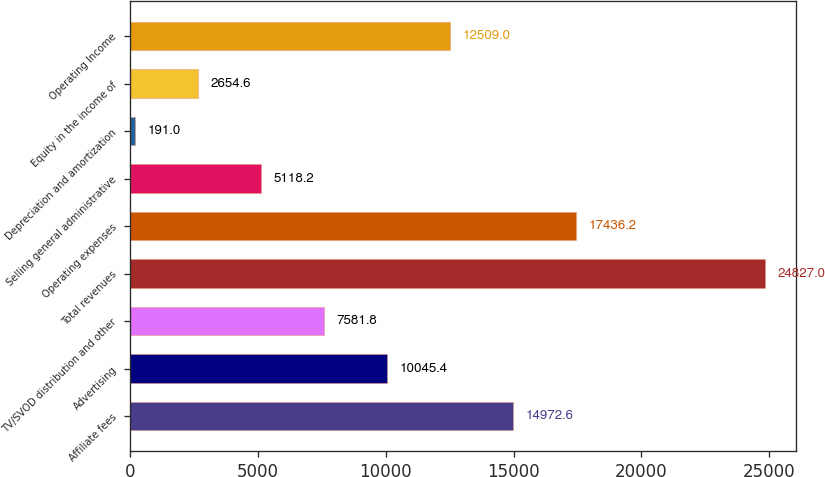Convert chart to OTSL. <chart><loc_0><loc_0><loc_500><loc_500><bar_chart><fcel>Affiliate fees<fcel>Advertising<fcel>TV/SVOD distribution and other<fcel>Total revenues<fcel>Operating expenses<fcel>Selling general administrative<fcel>Depreciation and amortization<fcel>Equity in the income of<fcel>Operating Income<nl><fcel>14972.6<fcel>10045.4<fcel>7581.8<fcel>24827<fcel>17436.2<fcel>5118.2<fcel>191<fcel>2654.6<fcel>12509<nl></chart> 